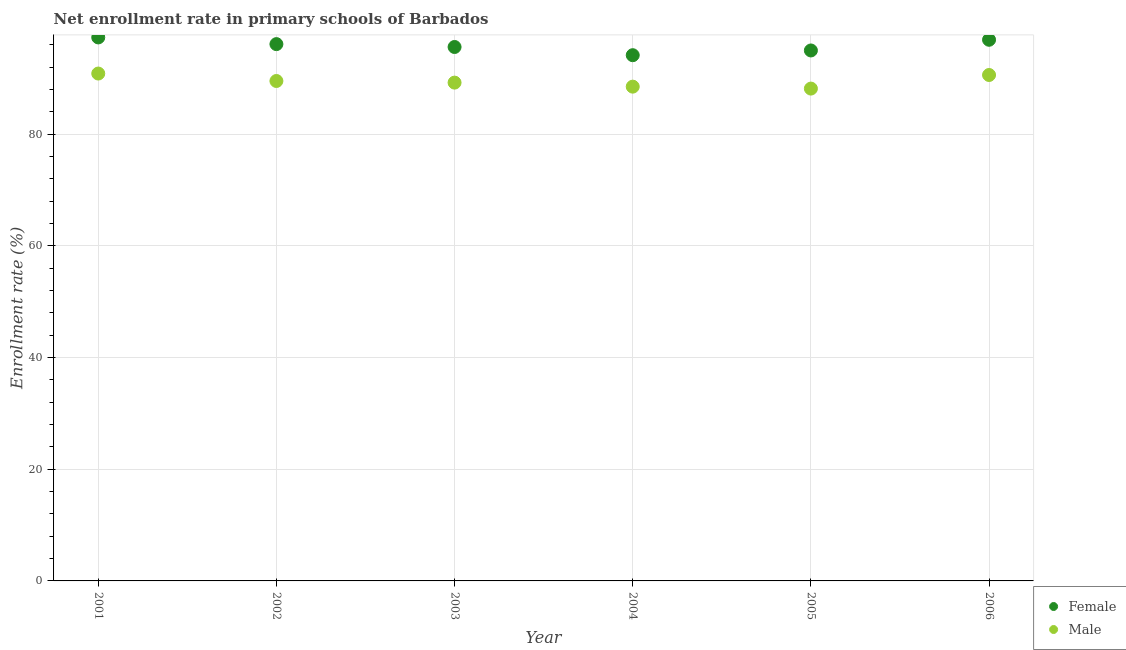How many different coloured dotlines are there?
Give a very brief answer. 2. Is the number of dotlines equal to the number of legend labels?
Give a very brief answer. Yes. What is the enrollment rate of female students in 2002?
Your response must be concise. 96.15. Across all years, what is the maximum enrollment rate of female students?
Your answer should be compact. 97.34. Across all years, what is the minimum enrollment rate of female students?
Provide a short and direct response. 94.16. In which year was the enrollment rate of female students maximum?
Keep it short and to the point. 2001. In which year was the enrollment rate of male students minimum?
Make the answer very short. 2005. What is the total enrollment rate of female students in the graph?
Your response must be concise. 575.21. What is the difference between the enrollment rate of male students in 2003 and that in 2005?
Make the answer very short. 1.07. What is the difference between the enrollment rate of male students in 2006 and the enrollment rate of female students in 2004?
Ensure brevity in your answer.  -3.54. What is the average enrollment rate of male students per year?
Provide a short and direct response. 89.5. In the year 2003, what is the difference between the enrollment rate of female students and enrollment rate of male students?
Provide a short and direct response. 6.38. What is the ratio of the enrollment rate of female students in 2002 to that in 2003?
Your answer should be compact. 1.01. Is the enrollment rate of female students in 2005 less than that in 2006?
Offer a terse response. Yes. Is the difference between the enrollment rate of female students in 2001 and 2003 greater than the difference between the enrollment rate of male students in 2001 and 2003?
Provide a short and direct response. Yes. What is the difference between the highest and the second highest enrollment rate of female students?
Your answer should be compact. 0.42. What is the difference between the highest and the lowest enrollment rate of female students?
Provide a succinct answer. 3.18. In how many years, is the enrollment rate of female students greater than the average enrollment rate of female students taken over all years?
Provide a succinct answer. 3. Does the enrollment rate of female students monotonically increase over the years?
Your answer should be compact. No. How many dotlines are there?
Ensure brevity in your answer.  2. What is the difference between two consecutive major ticks on the Y-axis?
Offer a very short reply. 20. Where does the legend appear in the graph?
Ensure brevity in your answer.  Bottom right. How many legend labels are there?
Provide a succinct answer. 2. How are the legend labels stacked?
Your answer should be very brief. Vertical. What is the title of the graph?
Your answer should be compact. Net enrollment rate in primary schools of Barbados. What is the label or title of the Y-axis?
Ensure brevity in your answer.  Enrollment rate (%). What is the Enrollment rate (%) of Female in 2001?
Your response must be concise. 97.34. What is the Enrollment rate (%) in Male in 2001?
Provide a short and direct response. 90.88. What is the Enrollment rate (%) in Female in 2002?
Your answer should be compact. 96.15. What is the Enrollment rate (%) of Male in 2002?
Offer a terse response. 89.54. What is the Enrollment rate (%) of Female in 2003?
Your response must be concise. 95.63. What is the Enrollment rate (%) of Male in 2003?
Your answer should be very brief. 89.25. What is the Enrollment rate (%) of Female in 2004?
Your response must be concise. 94.16. What is the Enrollment rate (%) in Male in 2004?
Provide a short and direct response. 88.53. What is the Enrollment rate (%) in Female in 2005?
Your response must be concise. 95.01. What is the Enrollment rate (%) of Male in 2005?
Give a very brief answer. 88.18. What is the Enrollment rate (%) in Female in 2006?
Make the answer very short. 96.92. What is the Enrollment rate (%) in Male in 2006?
Offer a terse response. 90.62. Across all years, what is the maximum Enrollment rate (%) in Female?
Your answer should be compact. 97.34. Across all years, what is the maximum Enrollment rate (%) of Male?
Make the answer very short. 90.88. Across all years, what is the minimum Enrollment rate (%) of Female?
Provide a succinct answer. 94.16. Across all years, what is the minimum Enrollment rate (%) of Male?
Your answer should be compact. 88.18. What is the total Enrollment rate (%) of Female in the graph?
Your answer should be compact. 575.21. What is the total Enrollment rate (%) in Male in the graph?
Make the answer very short. 536.99. What is the difference between the Enrollment rate (%) of Female in 2001 and that in 2002?
Offer a terse response. 1.2. What is the difference between the Enrollment rate (%) of Male in 2001 and that in 2002?
Your answer should be very brief. 1.33. What is the difference between the Enrollment rate (%) of Female in 2001 and that in 2003?
Offer a very short reply. 1.71. What is the difference between the Enrollment rate (%) in Male in 2001 and that in 2003?
Offer a very short reply. 1.63. What is the difference between the Enrollment rate (%) in Female in 2001 and that in 2004?
Your response must be concise. 3.18. What is the difference between the Enrollment rate (%) in Male in 2001 and that in 2004?
Ensure brevity in your answer.  2.35. What is the difference between the Enrollment rate (%) in Female in 2001 and that in 2005?
Offer a terse response. 2.33. What is the difference between the Enrollment rate (%) of Male in 2001 and that in 2005?
Your answer should be very brief. 2.69. What is the difference between the Enrollment rate (%) in Female in 2001 and that in 2006?
Keep it short and to the point. 0.42. What is the difference between the Enrollment rate (%) in Male in 2001 and that in 2006?
Give a very brief answer. 0.26. What is the difference between the Enrollment rate (%) in Female in 2002 and that in 2003?
Your answer should be very brief. 0.52. What is the difference between the Enrollment rate (%) of Male in 2002 and that in 2003?
Your response must be concise. 0.29. What is the difference between the Enrollment rate (%) of Female in 2002 and that in 2004?
Offer a terse response. 1.99. What is the difference between the Enrollment rate (%) of Male in 2002 and that in 2004?
Offer a terse response. 1.01. What is the difference between the Enrollment rate (%) in Female in 2002 and that in 2005?
Make the answer very short. 1.14. What is the difference between the Enrollment rate (%) in Male in 2002 and that in 2005?
Keep it short and to the point. 1.36. What is the difference between the Enrollment rate (%) in Female in 2002 and that in 2006?
Offer a terse response. -0.78. What is the difference between the Enrollment rate (%) in Male in 2002 and that in 2006?
Your response must be concise. -1.07. What is the difference between the Enrollment rate (%) of Female in 2003 and that in 2004?
Provide a succinct answer. 1.47. What is the difference between the Enrollment rate (%) of Male in 2003 and that in 2004?
Ensure brevity in your answer.  0.72. What is the difference between the Enrollment rate (%) in Female in 2003 and that in 2005?
Your answer should be compact. 0.62. What is the difference between the Enrollment rate (%) of Male in 2003 and that in 2005?
Offer a very short reply. 1.07. What is the difference between the Enrollment rate (%) in Female in 2003 and that in 2006?
Your answer should be very brief. -1.29. What is the difference between the Enrollment rate (%) in Male in 2003 and that in 2006?
Offer a terse response. -1.37. What is the difference between the Enrollment rate (%) in Female in 2004 and that in 2005?
Provide a short and direct response. -0.85. What is the difference between the Enrollment rate (%) of Male in 2004 and that in 2005?
Offer a very short reply. 0.35. What is the difference between the Enrollment rate (%) of Female in 2004 and that in 2006?
Your answer should be very brief. -2.76. What is the difference between the Enrollment rate (%) in Male in 2004 and that in 2006?
Your answer should be very brief. -2.09. What is the difference between the Enrollment rate (%) in Female in 2005 and that in 2006?
Provide a succinct answer. -1.91. What is the difference between the Enrollment rate (%) of Male in 2005 and that in 2006?
Your response must be concise. -2.43. What is the difference between the Enrollment rate (%) of Female in 2001 and the Enrollment rate (%) of Male in 2002?
Provide a short and direct response. 7.8. What is the difference between the Enrollment rate (%) of Female in 2001 and the Enrollment rate (%) of Male in 2003?
Your response must be concise. 8.09. What is the difference between the Enrollment rate (%) in Female in 2001 and the Enrollment rate (%) in Male in 2004?
Offer a terse response. 8.81. What is the difference between the Enrollment rate (%) in Female in 2001 and the Enrollment rate (%) in Male in 2005?
Offer a terse response. 9.16. What is the difference between the Enrollment rate (%) in Female in 2001 and the Enrollment rate (%) in Male in 2006?
Offer a very short reply. 6.73. What is the difference between the Enrollment rate (%) in Female in 2002 and the Enrollment rate (%) in Male in 2003?
Your answer should be very brief. 6.9. What is the difference between the Enrollment rate (%) of Female in 2002 and the Enrollment rate (%) of Male in 2004?
Offer a terse response. 7.62. What is the difference between the Enrollment rate (%) in Female in 2002 and the Enrollment rate (%) in Male in 2005?
Give a very brief answer. 7.96. What is the difference between the Enrollment rate (%) in Female in 2002 and the Enrollment rate (%) in Male in 2006?
Offer a very short reply. 5.53. What is the difference between the Enrollment rate (%) of Female in 2003 and the Enrollment rate (%) of Male in 2004?
Offer a terse response. 7.1. What is the difference between the Enrollment rate (%) in Female in 2003 and the Enrollment rate (%) in Male in 2005?
Your answer should be very brief. 7.45. What is the difference between the Enrollment rate (%) in Female in 2003 and the Enrollment rate (%) in Male in 2006?
Provide a short and direct response. 5.01. What is the difference between the Enrollment rate (%) in Female in 2004 and the Enrollment rate (%) in Male in 2005?
Ensure brevity in your answer.  5.98. What is the difference between the Enrollment rate (%) in Female in 2004 and the Enrollment rate (%) in Male in 2006?
Your response must be concise. 3.54. What is the difference between the Enrollment rate (%) of Female in 2005 and the Enrollment rate (%) of Male in 2006?
Provide a succinct answer. 4.39. What is the average Enrollment rate (%) in Female per year?
Your answer should be compact. 95.87. What is the average Enrollment rate (%) of Male per year?
Your answer should be compact. 89.5. In the year 2001, what is the difference between the Enrollment rate (%) in Female and Enrollment rate (%) in Male?
Provide a short and direct response. 6.47. In the year 2002, what is the difference between the Enrollment rate (%) of Female and Enrollment rate (%) of Male?
Provide a succinct answer. 6.6. In the year 2003, what is the difference between the Enrollment rate (%) in Female and Enrollment rate (%) in Male?
Offer a terse response. 6.38. In the year 2004, what is the difference between the Enrollment rate (%) of Female and Enrollment rate (%) of Male?
Offer a terse response. 5.63. In the year 2005, what is the difference between the Enrollment rate (%) of Female and Enrollment rate (%) of Male?
Provide a short and direct response. 6.83. In the year 2006, what is the difference between the Enrollment rate (%) of Female and Enrollment rate (%) of Male?
Keep it short and to the point. 6.31. What is the ratio of the Enrollment rate (%) of Female in 2001 to that in 2002?
Offer a very short reply. 1.01. What is the ratio of the Enrollment rate (%) of Male in 2001 to that in 2002?
Your answer should be very brief. 1.01. What is the ratio of the Enrollment rate (%) of Female in 2001 to that in 2003?
Keep it short and to the point. 1.02. What is the ratio of the Enrollment rate (%) of Male in 2001 to that in 2003?
Your answer should be very brief. 1.02. What is the ratio of the Enrollment rate (%) of Female in 2001 to that in 2004?
Make the answer very short. 1.03. What is the ratio of the Enrollment rate (%) in Male in 2001 to that in 2004?
Offer a terse response. 1.03. What is the ratio of the Enrollment rate (%) in Female in 2001 to that in 2005?
Your response must be concise. 1.02. What is the ratio of the Enrollment rate (%) in Male in 2001 to that in 2005?
Your answer should be very brief. 1.03. What is the ratio of the Enrollment rate (%) of Female in 2002 to that in 2003?
Offer a very short reply. 1.01. What is the ratio of the Enrollment rate (%) in Female in 2002 to that in 2004?
Offer a very short reply. 1.02. What is the ratio of the Enrollment rate (%) in Male in 2002 to that in 2004?
Keep it short and to the point. 1.01. What is the ratio of the Enrollment rate (%) of Male in 2002 to that in 2005?
Provide a succinct answer. 1.02. What is the ratio of the Enrollment rate (%) in Female in 2002 to that in 2006?
Your response must be concise. 0.99. What is the ratio of the Enrollment rate (%) in Female in 2003 to that in 2004?
Offer a very short reply. 1.02. What is the ratio of the Enrollment rate (%) in Male in 2003 to that in 2004?
Make the answer very short. 1.01. What is the ratio of the Enrollment rate (%) in Female in 2003 to that in 2005?
Ensure brevity in your answer.  1.01. What is the ratio of the Enrollment rate (%) of Male in 2003 to that in 2005?
Provide a succinct answer. 1.01. What is the ratio of the Enrollment rate (%) of Female in 2003 to that in 2006?
Keep it short and to the point. 0.99. What is the ratio of the Enrollment rate (%) of Male in 2003 to that in 2006?
Keep it short and to the point. 0.98. What is the ratio of the Enrollment rate (%) in Male in 2004 to that in 2005?
Your answer should be very brief. 1. What is the ratio of the Enrollment rate (%) in Female in 2004 to that in 2006?
Offer a very short reply. 0.97. What is the ratio of the Enrollment rate (%) of Male in 2004 to that in 2006?
Ensure brevity in your answer.  0.98. What is the ratio of the Enrollment rate (%) in Female in 2005 to that in 2006?
Your response must be concise. 0.98. What is the ratio of the Enrollment rate (%) in Male in 2005 to that in 2006?
Offer a very short reply. 0.97. What is the difference between the highest and the second highest Enrollment rate (%) of Female?
Make the answer very short. 0.42. What is the difference between the highest and the second highest Enrollment rate (%) of Male?
Make the answer very short. 0.26. What is the difference between the highest and the lowest Enrollment rate (%) in Female?
Provide a succinct answer. 3.18. What is the difference between the highest and the lowest Enrollment rate (%) in Male?
Offer a terse response. 2.69. 